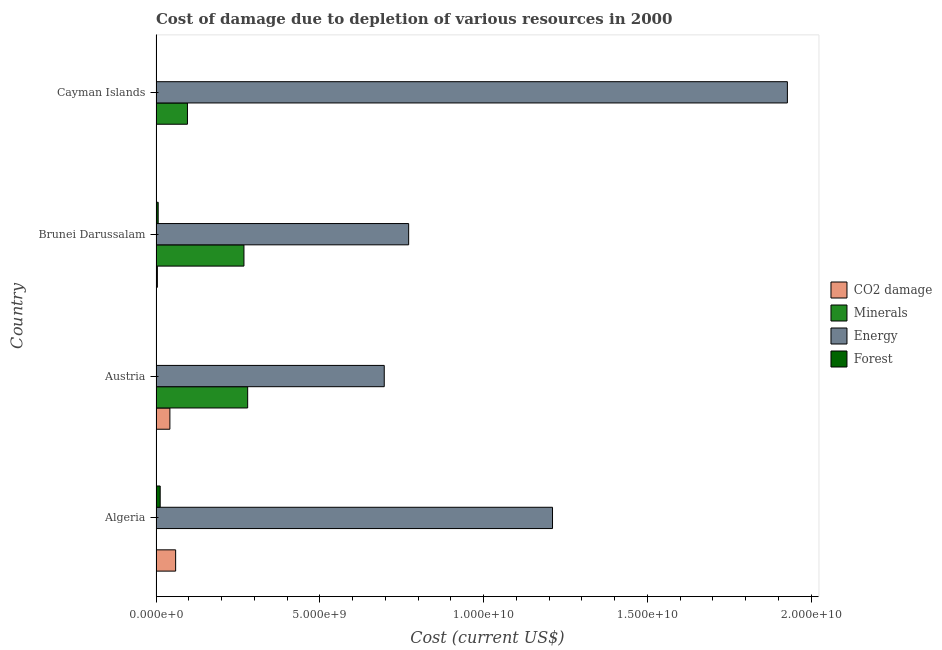How many different coloured bars are there?
Provide a short and direct response. 4. Are the number of bars per tick equal to the number of legend labels?
Your answer should be compact. Yes. What is the label of the 4th group of bars from the top?
Ensure brevity in your answer.  Algeria. In how many cases, is the number of bars for a given country not equal to the number of legend labels?
Ensure brevity in your answer.  0. What is the cost of damage due to depletion of coal in Cayman Islands?
Offer a very short reply. 3.10e+06. Across all countries, what is the maximum cost of damage due to depletion of energy?
Keep it short and to the point. 1.93e+1. Across all countries, what is the minimum cost of damage due to depletion of coal?
Your response must be concise. 3.10e+06. In which country was the cost of damage due to depletion of forests maximum?
Your answer should be compact. Algeria. In which country was the cost of damage due to depletion of minerals minimum?
Keep it short and to the point. Algeria. What is the total cost of damage due to depletion of coal in the graph?
Make the answer very short. 1.07e+09. What is the difference between the cost of damage due to depletion of forests in Algeria and that in Austria?
Make the answer very short. 1.27e+08. What is the difference between the cost of damage due to depletion of energy in Austria and the cost of damage due to depletion of minerals in Brunei Darussalam?
Provide a succinct answer. 4.28e+09. What is the average cost of damage due to depletion of minerals per country?
Keep it short and to the point. 1.61e+09. What is the difference between the cost of damage due to depletion of energy and cost of damage due to depletion of coal in Cayman Islands?
Make the answer very short. 1.93e+1. What is the ratio of the cost of damage due to depletion of minerals in Brunei Darussalam to that in Cayman Islands?
Offer a terse response. 2.8. What is the difference between the highest and the second highest cost of damage due to depletion of minerals?
Offer a very short reply. 1.13e+08. What is the difference between the highest and the lowest cost of damage due to depletion of energy?
Your answer should be very brief. 1.23e+1. Is the sum of the cost of damage due to depletion of forests in Austria and Cayman Islands greater than the maximum cost of damage due to depletion of coal across all countries?
Ensure brevity in your answer.  No. What does the 3rd bar from the top in Austria represents?
Provide a succinct answer. Minerals. What does the 2nd bar from the bottom in Brunei Darussalam represents?
Your answer should be compact. Minerals. Is it the case that in every country, the sum of the cost of damage due to depletion of coal and cost of damage due to depletion of minerals is greater than the cost of damage due to depletion of energy?
Your response must be concise. No. How many bars are there?
Offer a very short reply. 16. How many countries are there in the graph?
Ensure brevity in your answer.  4. What is the difference between two consecutive major ticks on the X-axis?
Your answer should be compact. 5.00e+09. Are the values on the major ticks of X-axis written in scientific E-notation?
Your answer should be very brief. Yes. Does the graph contain any zero values?
Give a very brief answer. No. Does the graph contain grids?
Offer a terse response. No. Where does the legend appear in the graph?
Your answer should be compact. Center right. How many legend labels are there?
Make the answer very short. 4. How are the legend labels stacked?
Provide a short and direct response. Vertical. What is the title of the graph?
Keep it short and to the point. Cost of damage due to depletion of various resources in 2000 . What is the label or title of the X-axis?
Ensure brevity in your answer.  Cost (current US$). What is the label or title of the Y-axis?
Keep it short and to the point. Country. What is the Cost (current US$) in CO2 damage in Algeria?
Ensure brevity in your answer.  5.99e+08. What is the Cost (current US$) of Minerals in Algeria?
Provide a succinct answer. 9.70e+06. What is the Cost (current US$) in Energy in Algeria?
Provide a short and direct response. 1.21e+1. What is the Cost (current US$) of Forest in Algeria?
Make the answer very short. 1.27e+08. What is the Cost (current US$) of CO2 damage in Austria?
Ensure brevity in your answer.  4.24e+08. What is the Cost (current US$) of Minerals in Austria?
Keep it short and to the point. 2.80e+09. What is the Cost (current US$) in Energy in Austria?
Ensure brevity in your answer.  6.97e+09. What is the Cost (current US$) in Forest in Austria?
Your answer should be compact. 9.14e+04. What is the Cost (current US$) of CO2 damage in Brunei Darussalam?
Your answer should be very brief. 4.16e+07. What is the Cost (current US$) in Minerals in Brunei Darussalam?
Your response must be concise. 2.69e+09. What is the Cost (current US$) of Energy in Brunei Darussalam?
Provide a succinct answer. 7.71e+09. What is the Cost (current US$) in Forest in Brunei Darussalam?
Offer a very short reply. 6.59e+07. What is the Cost (current US$) in CO2 damage in Cayman Islands?
Offer a terse response. 3.10e+06. What is the Cost (current US$) in Minerals in Cayman Islands?
Your answer should be very brief. 9.60e+08. What is the Cost (current US$) in Energy in Cayman Islands?
Your answer should be compact. 1.93e+1. What is the Cost (current US$) of Forest in Cayman Islands?
Your answer should be very brief. 4.92e+06. Across all countries, what is the maximum Cost (current US$) in CO2 damage?
Your answer should be very brief. 5.99e+08. Across all countries, what is the maximum Cost (current US$) in Minerals?
Give a very brief answer. 2.80e+09. Across all countries, what is the maximum Cost (current US$) in Energy?
Provide a succinct answer. 1.93e+1. Across all countries, what is the maximum Cost (current US$) of Forest?
Ensure brevity in your answer.  1.27e+08. Across all countries, what is the minimum Cost (current US$) of CO2 damage?
Provide a short and direct response. 3.10e+06. Across all countries, what is the minimum Cost (current US$) of Minerals?
Give a very brief answer. 9.70e+06. Across all countries, what is the minimum Cost (current US$) in Energy?
Provide a succinct answer. 6.97e+09. Across all countries, what is the minimum Cost (current US$) of Forest?
Provide a succinct answer. 9.14e+04. What is the total Cost (current US$) of CO2 damage in the graph?
Offer a terse response. 1.07e+09. What is the total Cost (current US$) in Minerals in the graph?
Keep it short and to the point. 6.45e+09. What is the total Cost (current US$) of Energy in the graph?
Your answer should be very brief. 4.61e+1. What is the total Cost (current US$) in Forest in the graph?
Your answer should be very brief. 1.98e+08. What is the difference between the Cost (current US$) of CO2 damage in Algeria and that in Austria?
Your answer should be very brief. 1.75e+08. What is the difference between the Cost (current US$) in Minerals in Algeria and that in Austria?
Keep it short and to the point. -2.79e+09. What is the difference between the Cost (current US$) in Energy in Algeria and that in Austria?
Make the answer very short. 5.14e+09. What is the difference between the Cost (current US$) of Forest in Algeria and that in Austria?
Your answer should be very brief. 1.27e+08. What is the difference between the Cost (current US$) of CO2 damage in Algeria and that in Brunei Darussalam?
Make the answer very short. 5.57e+08. What is the difference between the Cost (current US$) in Minerals in Algeria and that in Brunei Darussalam?
Make the answer very short. -2.68e+09. What is the difference between the Cost (current US$) in Energy in Algeria and that in Brunei Darussalam?
Keep it short and to the point. 4.39e+09. What is the difference between the Cost (current US$) in Forest in Algeria and that in Brunei Darussalam?
Ensure brevity in your answer.  6.14e+07. What is the difference between the Cost (current US$) of CO2 damage in Algeria and that in Cayman Islands?
Ensure brevity in your answer.  5.96e+08. What is the difference between the Cost (current US$) of Minerals in Algeria and that in Cayman Islands?
Ensure brevity in your answer.  -9.50e+08. What is the difference between the Cost (current US$) of Energy in Algeria and that in Cayman Islands?
Offer a terse response. -7.17e+09. What is the difference between the Cost (current US$) of Forest in Algeria and that in Cayman Islands?
Offer a very short reply. 1.22e+08. What is the difference between the Cost (current US$) in CO2 damage in Austria and that in Brunei Darussalam?
Provide a short and direct response. 3.82e+08. What is the difference between the Cost (current US$) in Minerals in Austria and that in Brunei Darussalam?
Ensure brevity in your answer.  1.13e+08. What is the difference between the Cost (current US$) of Energy in Austria and that in Brunei Darussalam?
Offer a terse response. -7.45e+08. What is the difference between the Cost (current US$) of Forest in Austria and that in Brunei Darussalam?
Provide a succinct answer. -6.58e+07. What is the difference between the Cost (current US$) of CO2 damage in Austria and that in Cayman Islands?
Offer a terse response. 4.20e+08. What is the difference between the Cost (current US$) of Minerals in Austria and that in Cayman Islands?
Offer a very short reply. 1.84e+09. What is the difference between the Cost (current US$) in Energy in Austria and that in Cayman Islands?
Offer a terse response. -1.23e+1. What is the difference between the Cost (current US$) in Forest in Austria and that in Cayman Islands?
Offer a terse response. -4.83e+06. What is the difference between the Cost (current US$) in CO2 damage in Brunei Darussalam and that in Cayman Islands?
Offer a very short reply. 3.85e+07. What is the difference between the Cost (current US$) of Minerals in Brunei Darussalam and that in Cayman Islands?
Provide a short and direct response. 1.73e+09. What is the difference between the Cost (current US$) in Energy in Brunei Darussalam and that in Cayman Islands?
Keep it short and to the point. -1.16e+1. What is the difference between the Cost (current US$) in Forest in Brunei Darussalam and that in Cayman Islands?
Provide a succinct answer. 6.10e+07. What is the difference between the Cost (current US$) of CO2 damage in Algeria and the Cost (current US$) of Minerals in Austria?
Keep it short and to the point. -2.20e+09. What is the difference between the Cost (current US$) of CO2 damage in Algeria and the Cost (current US$) of Energy in Austria?
Your answer should be compact. -6.37e+09. What is the difference between the Cost (current US$) of CO2 damage in Algeria and the Cost (current US$) of Forest in Austria?
Offer a terse response. 5.99e+08. What is the difference between the Cost (current US$) of Minerals in Algeria and the Cost (current US$) of Energy in Austria?
Make the answer very short. -6.96e+09. What is the difference between the Cost (current US$) in Minerals in Algeria and the Cost (current US$) in Forest in Austria?
Give a very brief answer. 9.60e+06. What is the difference between the Cost (current US$) of Energy in Algeria and the Cost (current US$) of Forest in Austria?
Keep it short and to the point. 1.21e+1. What is the difference between the Cost (current US$) of CO2 damage in Algeria and the Cost (current US$) of Minerals in Brunei Darussalam?
Give a very brief answer. -2.09e+09. What is the difference between the Cost (current US$) in CO2 damage in Algeria and the Cost (current US$) in Energy in Brunei Darussalam?
Provide a short and direct response. -7.12e+09. What is the difference between the Cost (current US$) of CO2 damage in Algeria and the Cost (current US$) of Forest in Brunei Darussalam?
Give a very brief answer. 5.33e+08. What is the difference between the Cost (current US$) in Minerals in Algeria and the Cost (current US$) in Energy in Brunei Darussalam?
Ensure brevity in your answer.  -7.70e+09. What is the difference between the Cost (current US$) of Minerals in Algeria and the Cost (current US$) of Forest in Brunei Darussalam?
Give a very brief answer. -5.62e+07. What is the difference between the Cost (current US$) in Energy in Algeria and the Cost (current US$) in Forest in Brunei Darussalam?
Make the answer very short. 1.20e+1. What is the difference between the Cost (current US$) in CO2 damage in Algeria and the Cost (current US$) in Minerals in Cayman Islands?
Keep it short and to the point. -3.61e+08. What is the difference between the Cost (current US$) of CO2 damage in Algeria and the Cost (current US$) of Energy in Cayman Islands?
Make the answer very short. -1.87e+1. What is the difference between the Cost (current US$) in CO2 damage in Algeria and the Cost (current US$) in Forest in Cayman Islands?
Your response must be concise. 5.94e+08. What is the difference between the Cost (current US$) in Minerals in Algeria and the Cost (current US$) in Energy in Cayman Islands?
Your answer should be compact. -1.93e+1. What is the difference between the Cost (current US$) of Minerals in Algeria and the Cost (current US$) of Forest in Cayman Islands?
Ensure brevity in your answer.  4.78e+06. What is the difference between the Cost (current US$) in Energy in Algeria and the Cost (current US$) in Forest in Cayman Islands?
Offer a very short reply. 1.21e+1. What is the difference between the Cost (current US$) of CO2 damage in Austria and the Cost (current US$) of Minerals in Brunei Darussalam?
Give a very brief answer. -2.26e+09. What is the difference between the Cost (current US$) of CO2 damage in Austria and the Cost (current US$) of Energy in Brunei Darussalam?
Offer a very short reply. -7.29e+09. What is the difference between the Cost (current US$) in CO2 damage in Austria and the Cost (current US$) in Forest in Brunei Darussalam?
Give a very brief answer. 3.58e+08. What is the difference between the Cost (current US$) of Minerals in Austria and the Cost (current US$) of Energy in Brunei Darussalam?
Offer a very short reply. -4.92e+09. What is the difference between the Cost (current US$) of Minerals in Austria and the Cost (current US$) of Forest in Brunei Darussalam?
Make the answer very short. 2.73e+09. What is the difference between the Cost (current US$) of Energy in Austria and the Cost (current US$) of Forest in Brunei Darussalam?
Offer a terse response. 6.90e+09. What is the difference between the Cost (current US$) of CO2 damage in Austria and the Cost (current US$) of Minerals in Cayman Islands?
Provide a succinct answer. -5.36e+08. What is the difference between the Cost (current US$) of CO2 damage in Austria and the Cost (current US$) of Energy in Cayman Islands?
Provide a short and direct response. -1.89e+1. What is the difference between the Cost (current US$) in CO2 damage in Austria and the Cost (current US$) in Forest in Cayman Islands?
Provide a short and direct response. 4.19e+08. What is the difference between the Cost (current US$) of Minerals in Austria and the Cost (current US$) of Energy in Cayman Islands?
Your answer should be very brief. -1.65e+1. What is the difference between the Cost (current US$) in Minerals in Austria and the Cost (current US$) in Forest in Cayman Islands?
Provide a succinct answer. 2.79e+09. What is the difference between the Cost (current US$) of Energy in Austria and the Cost (current US$) of Forest in Cayman Islands?
Your answer should be compact. 6.96e+09. What is the difference between the Cost (current US$) of CO2 damage in Brunei Darussalam and the Cost (current US$) of Minerals in Cayman Islands?
Provide a succinct answer. -9.18e+08. What is the difference between the Cost (current US$) of CO2 damage in Brunei Darussalam and the Cost (current US$) of Energy in Cayman Islands?
Provide a short and direct response. -1.92e+1. What is the difference between the Cost (current US$) of CO2 damage in Brunei Darussalam and the Cost (current US$) of Forest in Cayman Islands?
Your answer should be very brief. 3.67e+07. What is the difference between the Cost (current US$) of Minerals in Brunei Darussalam and the Cost (current US$) of Energy in Cayman Islands?
Your response must be concise. -1.66e+1. What is the difference between the Cost (current US$) of Minerals in Brunei Darussalam and the Cost (current US$) of Forest in Cayman Islands?
Give a very brief answer. 2.68e+09. What is the difference between the Cost (current US$) in Energy in Brunei Darussalam and the Cost (current US$) in Forest in Cayman Islands?
Provide a short and direct response. 7.71e+09. What is the average Cost (current US$) of CO2 damage per country?
Ensure brevity in your answer.  2.67e+08. What is the average Cost (current US$) in Minerals per country?
Your answer should be very brief. 1.61e+09. What is the average Cost (current US$) in Energy per country?
Your answer should be very brief. 1.15e+1. What is the average Cost (current US$) in Forest per country?
Your answer should be very brief. 4.96e+07. What is the difference between the Cost (current US$) in CO2 damage and Cost (current US$) in Minerals in Algeria?
Provide a succinct answer. 5.89e+08. What is the difference between the Cost (current US$) of CO2 damage and Cost (current US$) of Energy in Algeria?
Your answer should be very brief. -1.15e+1. What is the difference between the Cost (current US$) in CO2 damage and Cost (current US$) in Forest in Algeria?
Your answer should be very brief. 4.72e+08. What is the difference between the Cost (current US$) in Minerals and Cost (current US$) in Energy in Algeria?
Offer a very short reply. -1.21e+1. What is the difference between the Cost (current US$) of Minerals and Cost (current US$) of Forest in Algeria?
Your answer should be very brief. -1.18e+08. What is the difference between the Cost (current US$) in Energy and Cost (current US$) in Forest in Algeria?
Your answer should be very brief. 1.20e+1. What is the difference between the Cost (current US$) in CO2 damage and Cost (current US$) in Minerals in Austria?
Make the answer very short. -2.37e+09. What is the difference between the Cost (current US$) in CO2 damage and Cost (current US$) in Energy in Austria?
Your response must be concise. -6.55e+09. What is the difference between the Cost (current US$) in CO2 damage and Cost (current US$) in Forest in Austria?
Your response must be concise. 4.23e+08. What is the difference between the Cost (current US$) in Minerals and Cost (current US$) in Energy in Austria?
Make the answer very short. -4.17e+09. What is the difference between the Cost (current US$) in Minerals and Cost (current US$) in Forest in Austria?
Keep it short and to the point. 2.80e+09. What is the difference between the Cost (current US$) in Energy and Cost (current US$) in Forest in Austria?
Ensure brevity in your answer.  6.97e+09. What is the difference between the Cost (current US$) of CO2 damage and Cost (current US$) of Minerals in Brunei Darussalam?
Provide a succinct answer. -2.64e+09. What is the difference between the Cost (current US$) in CO2 damage and Cost (current US$) in Energy in Brunei Darussalam?
Your answer should be compact. -7.67e+09. What is the difference between the Cost (current US$) of CO2 damage and Cost (current US$) of Forest in Brunei Darussalam?
Make the answer very short. -2.43e+07. What is the difference between the Cost (current US$) in Minerals and Cost (current US$) in Energy in Brunei Darussalam?
Your answer should be very brief. -5.03e+09. What is the difference between the Cost (current US$) in Minerals and Cost (current US$) in Forest in Brunei Darussalam?
Provide a succinct answer. 2.62e+09. What is the difference between the Cost (current US$) in Energy and Cost (current US$) in Forest in Brunei Darussalam?
Offer a very short reply. 7.65e+09. What is the difference between the Cost (current US$) in CO2 damage and Cost (current US$) in Minerals in Cayman Islands?
Provide a succinct answer. -9.57e+08. What is the difference between the Cost (current US$) in CO2 damage and Cost (current US$) in Energy in Cayman Islands?
Make the answer very short. -1.93e+1. What is the difference between the Cost (current US$) of CO2 damage and Cost (current US$) of Forest in Cayman Islands?
Your answer should be very brief. -1.82e+06. What is the difference between the Cost (current US$) in Minerals and Cost (current US$) in Energy in Cayman Islands?
Provide a succinct answer. -1.83e+1. What is the difference between the Cost (current US$) in Minerals and Cost (current US$) in Forest in Cayman Islands?
Your answer should be very brief. 9.55e+08. What is the difference between the Cost (current US$) in Energy and Cost (current US$) in Forest in Cayman Islands?
Your answer should be compact. 1.93e+1. What is the ratio of the Cost (current US$) in CO2 damage in Algeria to that in Austria?
Provide a succinct answer. 1.41. What is the ratio of the Cost (current US$) of Minerals in Algeria to that in Austria?
Offer a very short reply. 0. What is the ratio of the Cost (current US$) in Energy in Algeria to that in Austria?
Your answer should be compact. 1.74. What is the ratio of the Cost (current US$) of Forest in Algeria to that in Austria?
Offer a very short reply. 1393.2. What is the ratio of the Cost (current US$) of CO2 damage in Algeria to that in Brunei Darussalam?
Your answer should be compact. 14.4. What is the ratio of the Cost (current US$) of Minerals in Algeria to that in Brunei Darussalam?
Offer a very short reply. 0. What is the ratio of the Cost (current US$) in Energy in Algeria to that in Brunei Darussalam?
Offer a very short reply. 1.57. What is the ratio of the Cost (current US$) of Forest in Algeria to that in Brunei Darussalam?
Provide a succinct answer. 1.93. What is the ratio of the Cost (current US$) in CO2 damage in Algeria to that in Cayman Islands?
Give a very brief answer. 193.38. What is the ratio of the Cost (current US$) of Minerals in Algeria to that in Cayman Islands?
Your answer should be compact. 0.01. What is the ratio of the Cost (current US$) in Energy in Algeria to that in Cayman Islands?
Provide a short and direct response. 0.63. What is the ratio of the Cost (current US$) in Forest in Algeria to that in Cayman Islands?
Offer a very short reply. 25.89. What is the ratio of the Cost (current US$) of CO2 damage in Austria to that in Brunei Darussalam?
Offer a terse response. 10.19. What is the ratio of the Cost (current US$) in Minerals in Austria to that in Brunei Darussalam?
Provide a succinct answer. 1.04. What is the ratio of the Cost (current US$) in Energy in Austria to that in Brunei Darussalam?
Offer a terse response. 0.9. What is the ratio of the Cost (current US$) of Forest in Austria to that in Brunei Darussalam?
Offer a very short reply. 0. What is the ratio of the Cost (current US$) in CO2 damage in Austria to that in Cayman Islands?
Ensure brevity in your answer.  136.77. What is the ratio of the Cost (current US$) in Minerals in Austria to that in Cayman Islands?
Provide a succinct answer. 2.92. What is the ratio of the Cost (current US$) of Energy in Austria to that in Cayman Islands?
Make the answer very short. 0.36. What is the ratio of the Cost (current US$) in Forest in Austria to that in Cayman Islands?
Your response must be concise. 0.02. What is the ratio of the Cost (current US$) of CO2 damage in Brunei Darussalam to that in Cayman Islands?
Make the answer very short. 13.43. What is the ratio of the Cost (current US$) of Minerals in Brunei Darussalam to that in Cayman Islands?
Your answer should be very brief. 2.8. What is the ratio of the Cost (current US$) of Energy in Brunei Darussalam to that in Cayman Islands?
Your answer should be very brief. 0.4. What is the ratio of the Cost (current US$) in Forest in Brunei Darussalam to that in Cayman Islands?
Ensure brevity in your answer.  13.4. What is the difference between the highest and the second highest Cost (current US$) in CO2 damage?
Keep it short and to the point. 1.75e+08. What is the difference between the highest and the second highest Cost (current US$) of Minerals?
Keep it short and to the point. 1.13e+08. What is the difference between the highest and the second highest Cost (current US$) of Energy?
Your answer should be compact. 7.17e+09. What is the difference between the highest and the second highest Cost (current US$) of Forest?
Your response must be concise. 6.14e+07. What is the difference between the highest and the lowest Cost (current US$) of CO2 damage?
Keep it short and to the point. 5.96e+08. What is the difference between the highest and the lowest Cost (current US$) of Minerals?
Keep it short and to the point. 2.79e+09. What is the difference between the highest and the lowest Cost (current US$) in Energy?
Ensure brevity in your answer.  1.23e+1. What is the difference between the highest and the lowest Cost (current US$) of Forest?
Offer a very short reply. 1.27e+08. 